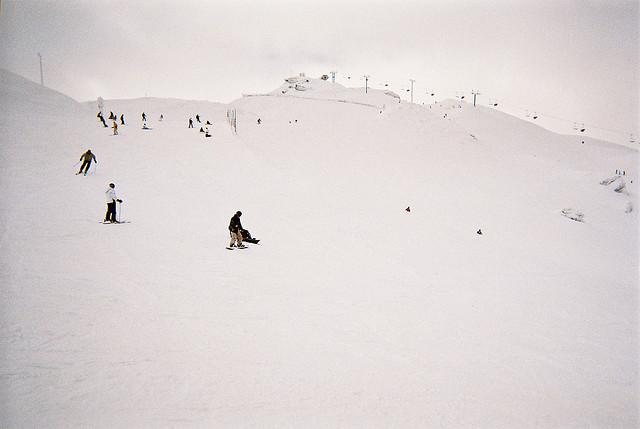How many skiers are there?
Short answer required. 20. Is the man wearing light clothing?
Be succinct. No. Which color is dominant?
Answer briefly. White. What is the weather like?
Answer briefly. Cold. What time of year is this?
Keep it brief. Winter. How many people in the picture?
Give a very brief answer. 15. How many people are in this picture?
Write a very short answer. 20. What are the white fluffy things?
Write a very short answer. Snow. What is this person riding?
Answer briefly. Skis. What animal is in the picture?
Answer briefly. Human. Is this a downhill skier or a ski jumper?
Be succinct. Downhill. Are these people skiing at night?
Be succinct. No. What color is the skier's pants?
Keep it brief. Black. What sport is this?
Give a very brief answer. Skiing. Is the snow deep?
Answer briefly. Yes. How many people are pictured?
Answer briefly. 21. Is this picture dark?
Short answer required. No. How many people are skiing?
Quick response, please. Many. What color is seen besides white?
Concise answer only. Black. Where is the bird?
Short answer required. Sky. 